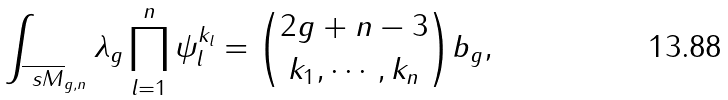<formula> <loc_0><loc_0><loc_500><loc_500>\int _ { \overline { \ s M } _ { g , n } } \lambda _ { g } \prod ^ { n } _ { l = 1 } \psi ^ { k _ { l } } _ { l } = \binom { 2 g + n - 3 } { k _ { 1 } , \cdots , k _ { n } } b _ { g } ,</formula> 